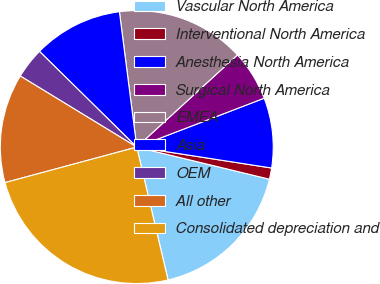Convert chart to OTSL. <chart><loc_0><loc_0><loc_500><loc_500><pie_chart><fcel>Vascular North America<fcel>Interventional North America<fcel>Anesthesia North America<fcel>Surgical North America<fcel>EMEA<fcel>Asia<fcel>OEM<fcel>All other<fcel>Consolidated depreciation and<nl><fcel>17.54%<fcel>1.33%<fcel>8.28%<fcel>5.97%<fcel>15.23%<fcel>10.6%<fcel>3.65%<fcel>12.91%<fcel>24.49%<nl></chart> 